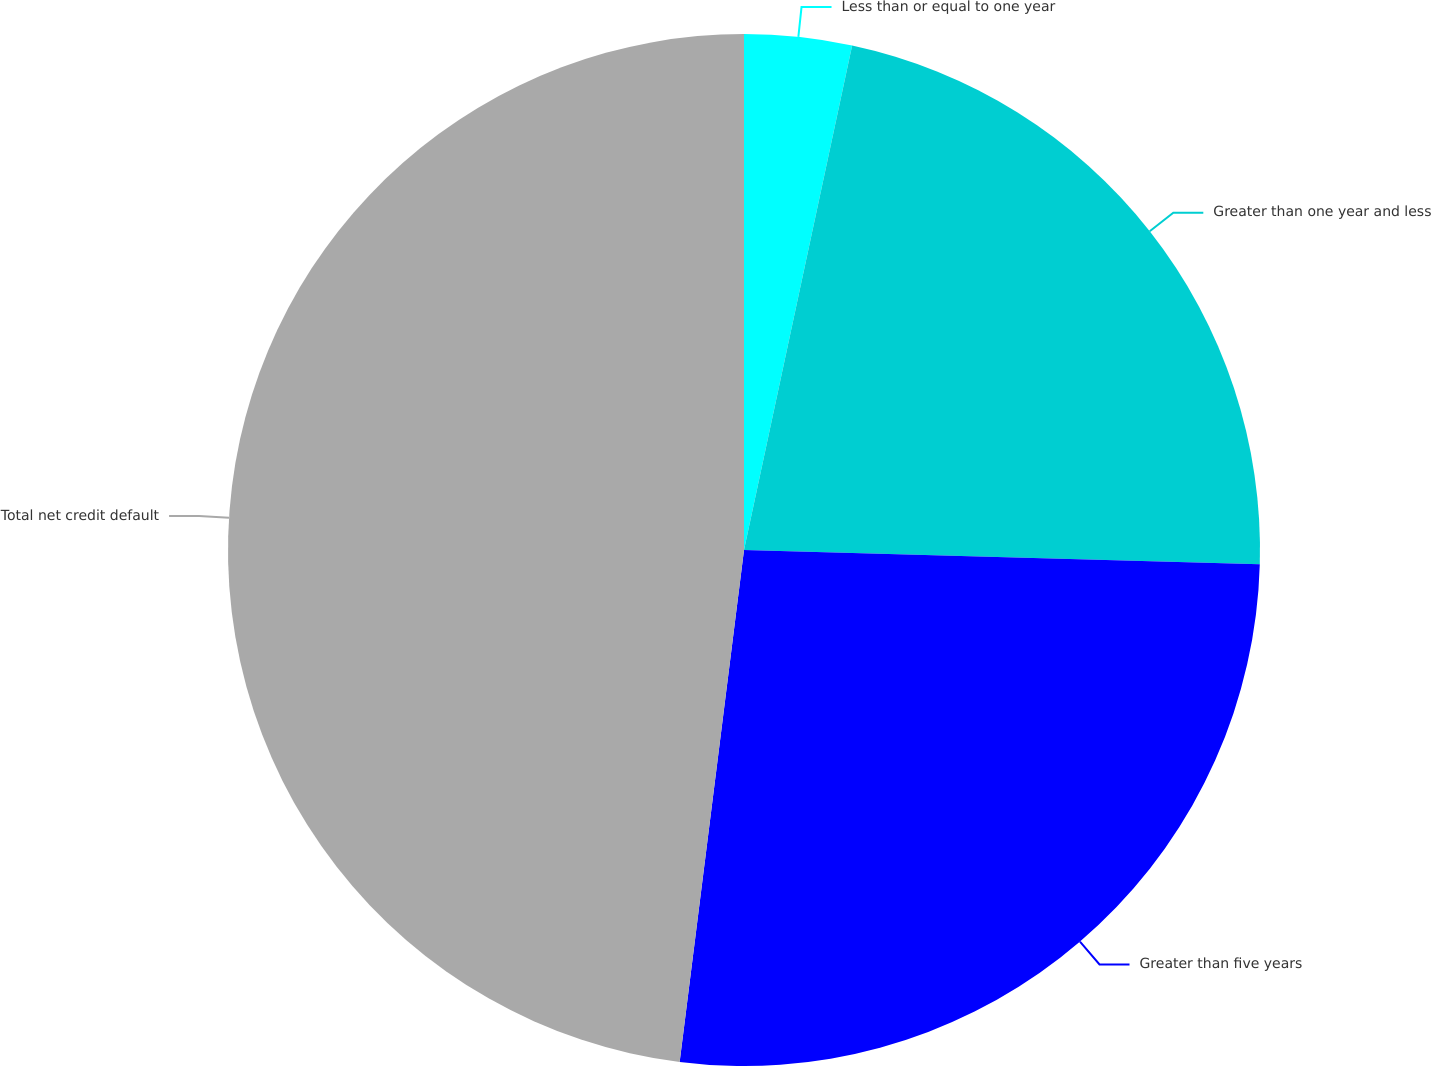<chart> <loc_0><loc_0><loc_500><loc_500><pie_chart><fcel>Less than or equal to one year<fcel>Greater than one year and less<fcel>Greater than five years<fcel>Total net credit default<nl><fcel>3.36%<fcel>22.08%<fcel>26.55%<fcel>48.01%<nl></chart> 